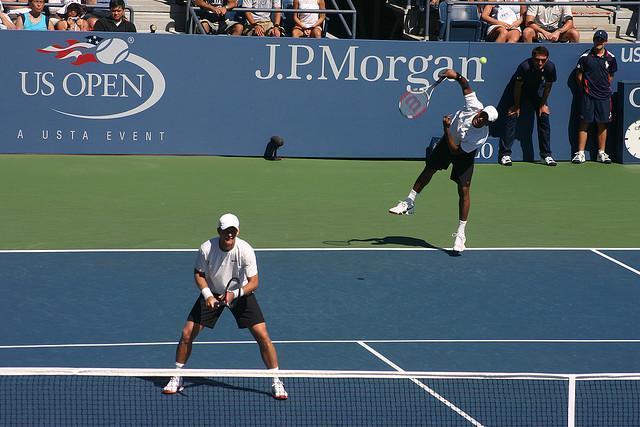How many tennis players are on the tennis court?
Give a very brief answer. 2. How many people are there?
Give a very brief answer. 5. 